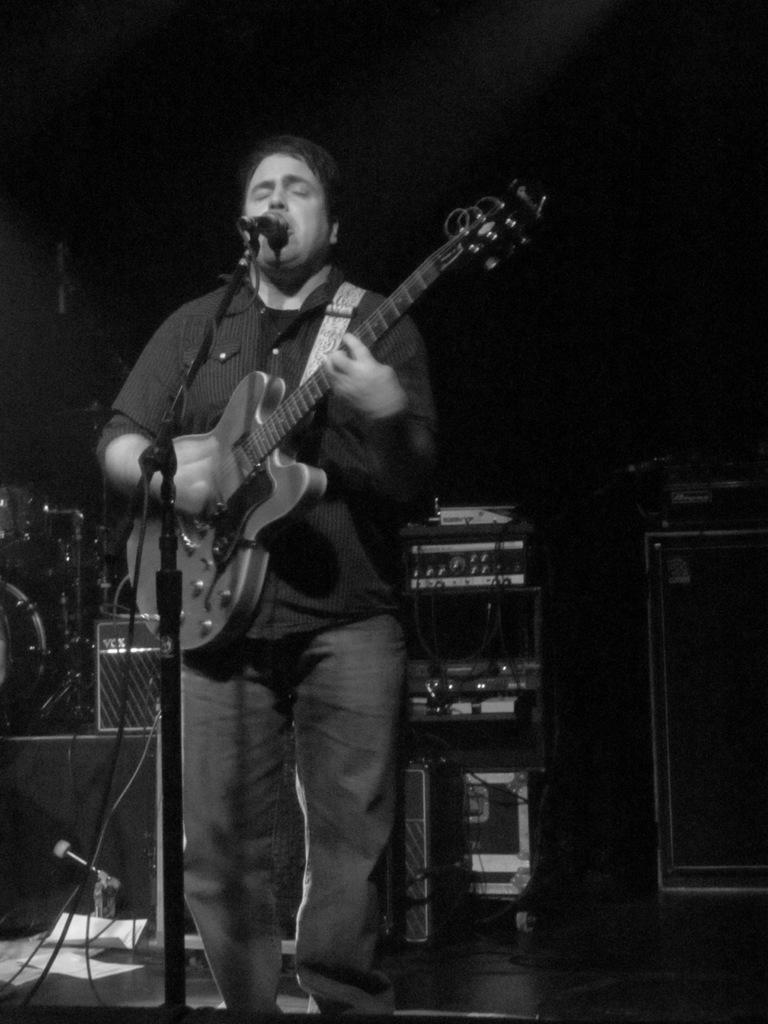What is the man in the image doing? The man is singing on a microphone and holding a guitar. What is the man holding in the image? The man is holding a guitar. What can be seen on the floor in the image? There are papers on the floor. What other musical instruments are visible in the image? There are musical instruments visible behind the man. How does the quince contribute to the man's performance in the image? There is no quince present in the image, so it cannot contribute to the man's performance. 